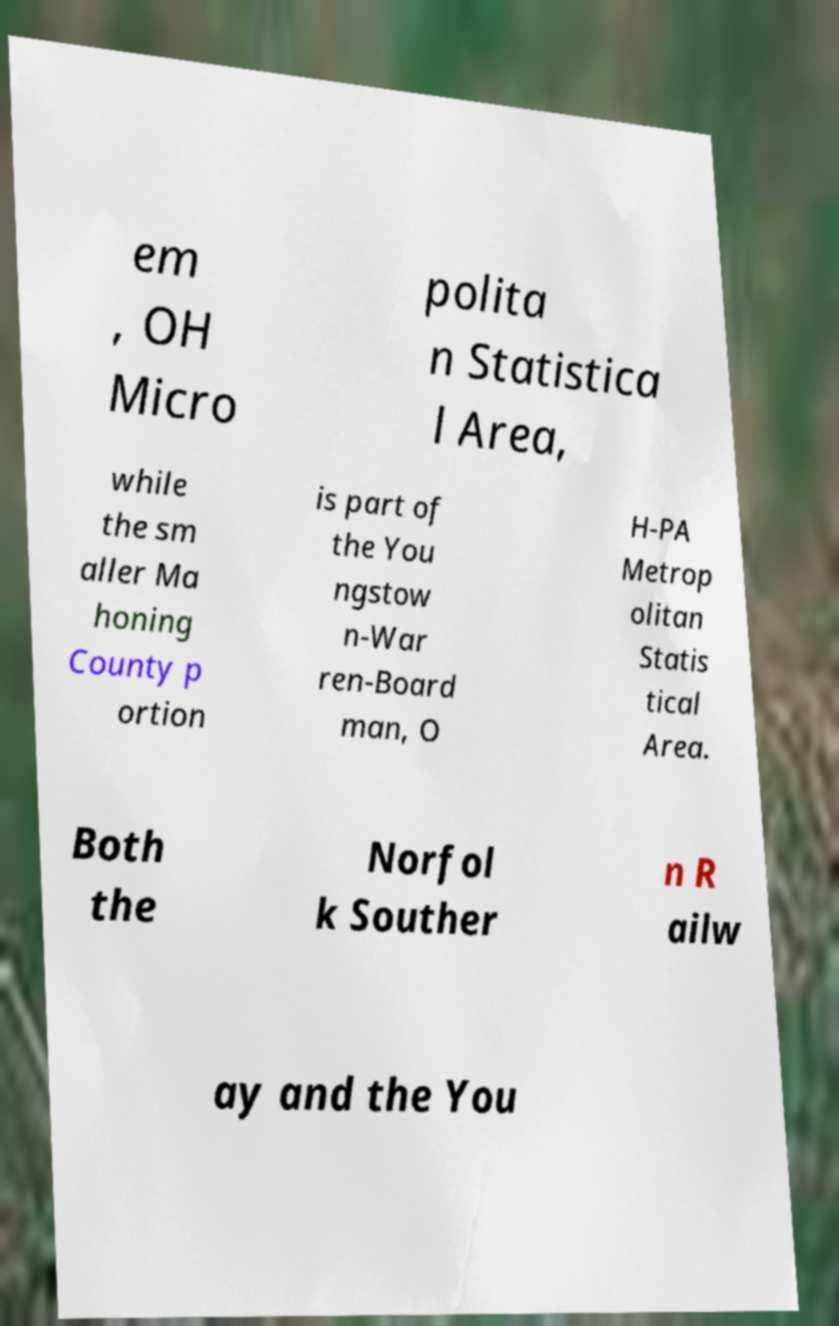I need the written content from this picture converted into text. Can you do that? em , OH Micro polita n Statistica l Area, while the sm aller Ma honing County p ortion is part of the You ngstow n-War ren-Board man, O H-PA Metrop olitan Statis tical Area. Both the Norfol k Souther n R ailw ay and the You 